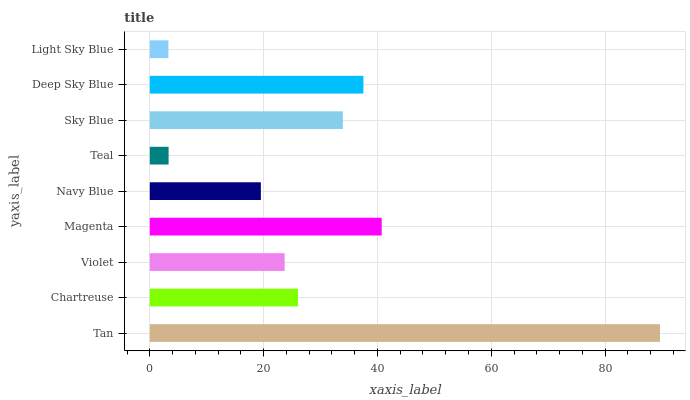Is Light Sky Blue the minimum?
Answer yes or no. Yes. Is Tan the maximum?
Answer yes or no. Yes. Is Chartreuse the minimum?
Answer yes or no. No. Is Chartreuse the maximum?
Answer yes or no. No. Is Tan greater than Chartreuse?
Answer yes or no. Yes. Is Chartreuse less than Tan?
Answer yes or no. Yes. Is Chartreuse greater than Tan?
Answer yes or no. No. Is Tan less than Chartreuse?
Answer yes or no. No. Is Chartreuse the high median?
Answer yes or no. Yes. Is Chartreuse the low median?
Answer yes or no. Yes. Is Sky Blue the high median?
Answer yes or no. No. Is Deep Sky Blue the low median?
Answer yes or no. No. 